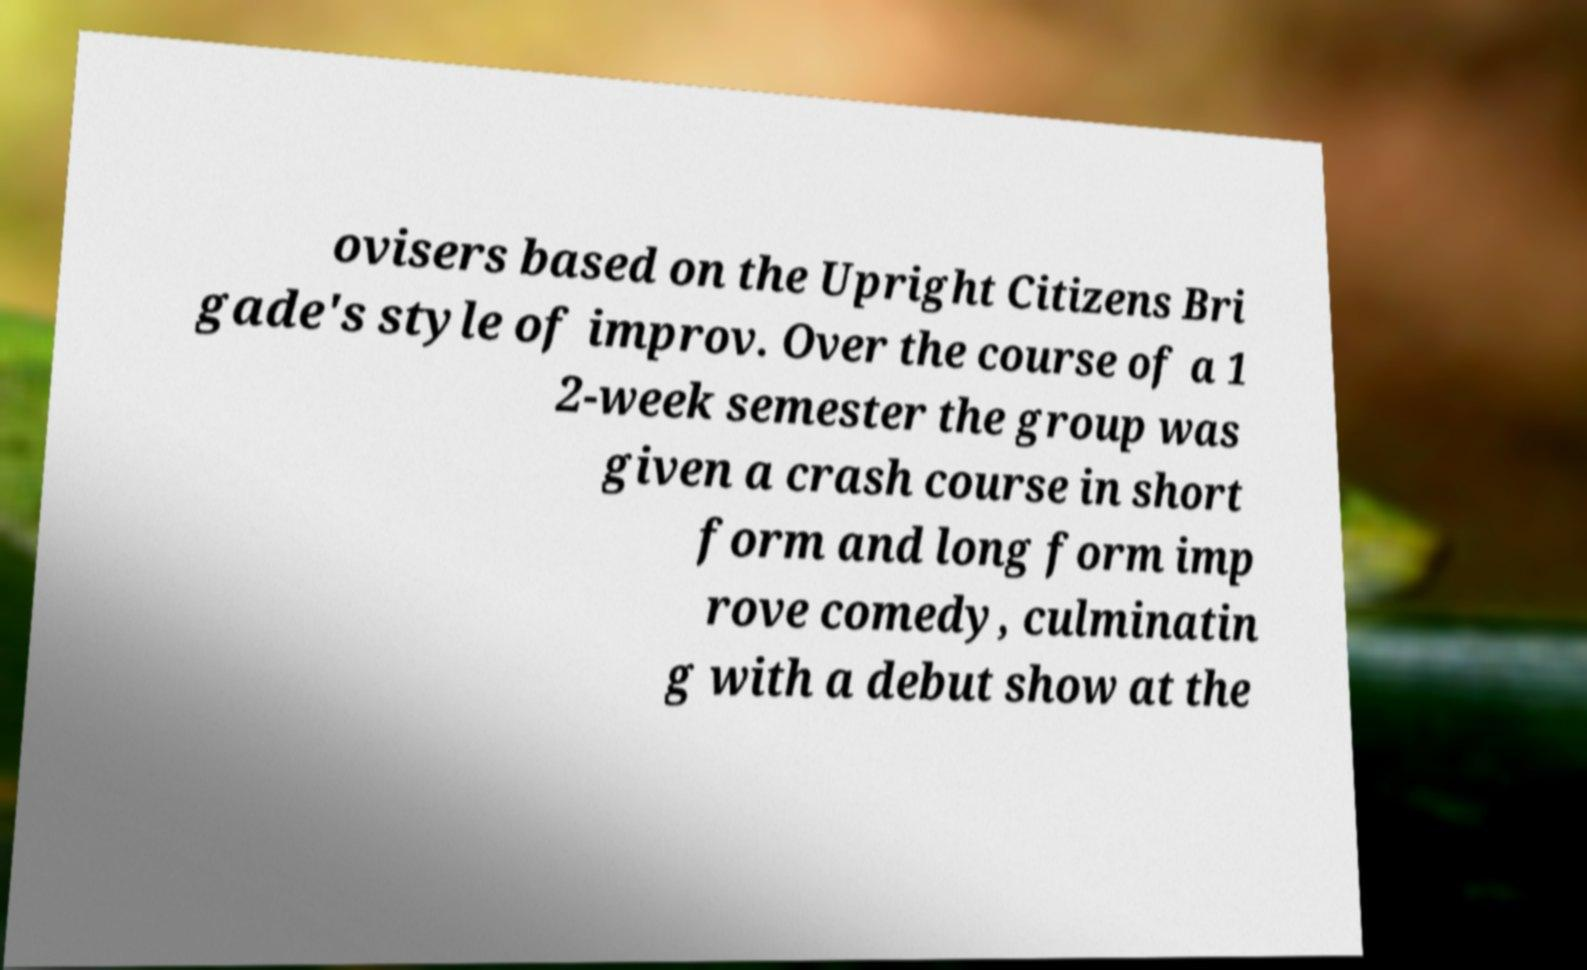Please identify and transcribe the text found in this image. ovisers based on the Upright Citizens Bri gade's style of improv. Over the course of a 1 2-week semester the group was given a crash course in short form and long form imp rove comedy, culminatin g with a debut show at the 